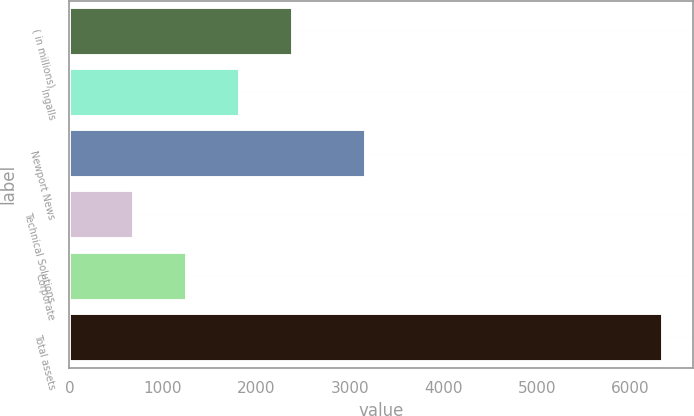<chart> <loc_0><loc_0><loc_500><loc_500><bar_chart><fcel>( in millions)<fcel>Ingalls<fcel>Newport News<fcel>Technical Solutions<fcel>Corporate<fcel>Total assets<nl><fcel>2390<fcel>1824<fcel>3169<fcel>692<fcel>1258<fcel>6352<nl></chart> 